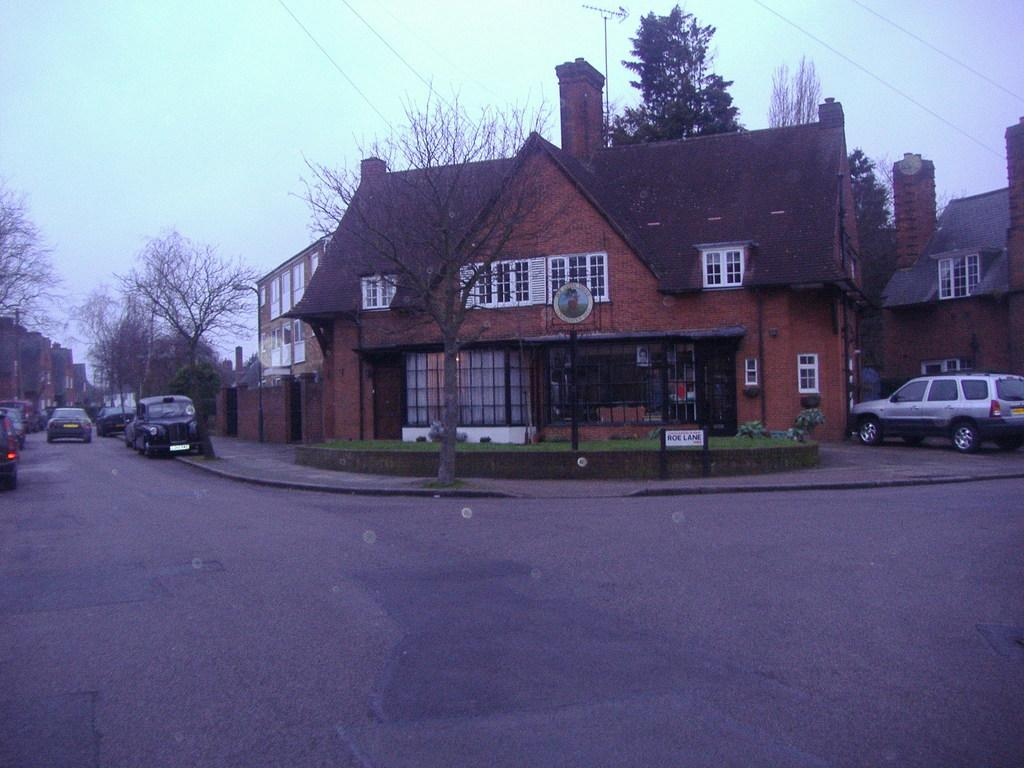What type of structures can be seen in the image? There are buildings in the image. What other natural elements are present in the image? There are trees in the image. What mode of transportation can be seen on the road at the bottom of the image? There are cars on the road at the bottom of the image. What is visible in the background of the image? There is sky visible in the background of the image. Are there any additional features in the background of the image? Yes, there are wires in the background of the image. Can you tell me how many crates are stacked on top of each other in the image? There are no crates present in the image. What is the writing on the buildings in the image? There is no writing visible on the buildings in the image. 